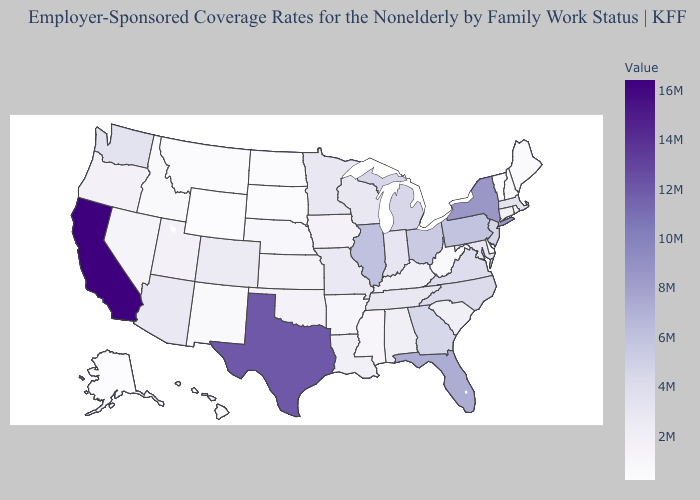Does North Dakota have the lowest value in the MidWest?
Answer briefly. Yes. Does Pennsylvania have the lowest value in the Northeast?
Quick response, please. No. Does Tennessee have the lowest value in the USA?
Concise answer only. No. 